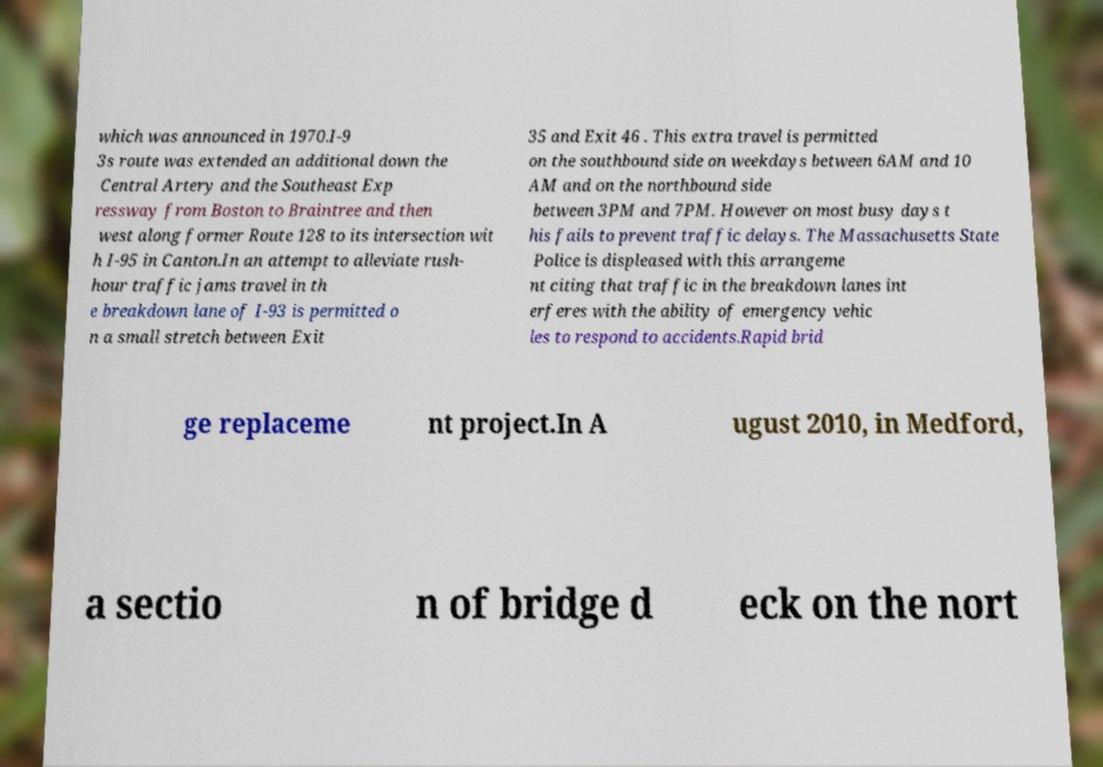Please identify and transcribe the text found in this image. which was announced in 1970.I-9 3s route was extended an additional down the Central Artery and the Southeast Exp ressway from Boston to Braintree and then west along former Route 128 to its intersection wit h I-95 in Canton.In an attempt to alleviate rush- hour traffic jams travel in th e breakdown lane of I-93 is permitted o n a small stretch between Exit 35 and Exit 46 . This extra travel is permitted on the southbound side on weekdays between 6AM and 10 AM and on the northbound side between 3PM and 7PM. However on most busy days t his fails to prevent traffic delays. The Massachusetts State Police is displeased with this arrangeme nt citing that traffic in the breakdown lanes int erferes with the ability of emergency vehic les to respond to accidents.Rapid brid ge replaceme nt project.In A ugust 2010, in Medford, a sectio n of bridge d eck on the nort 